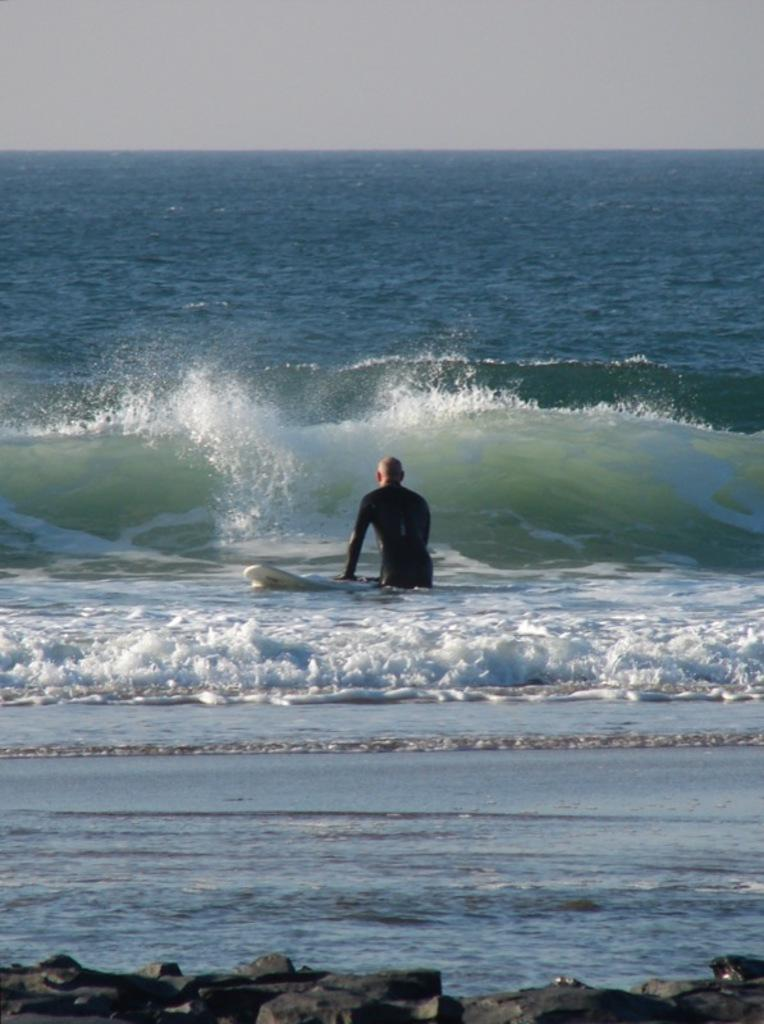What is located at the bottom of the image? There are stones at the bottom of the image. What can be seen in the background of the image? There is water visible in the background of the image. Who is present in the image? There is a person in the image. What is the person holding? The person is holding a surfboard. What is visible at the top of the image? The sky is visible at the top of the image. How many chairs are visible in the image? There are no chairs present in the image. What type of wrist accessory is the person wearing in the image? The image does not show the person's wrist, so it is not possible to determine if they are wearing any wrist accessory. 